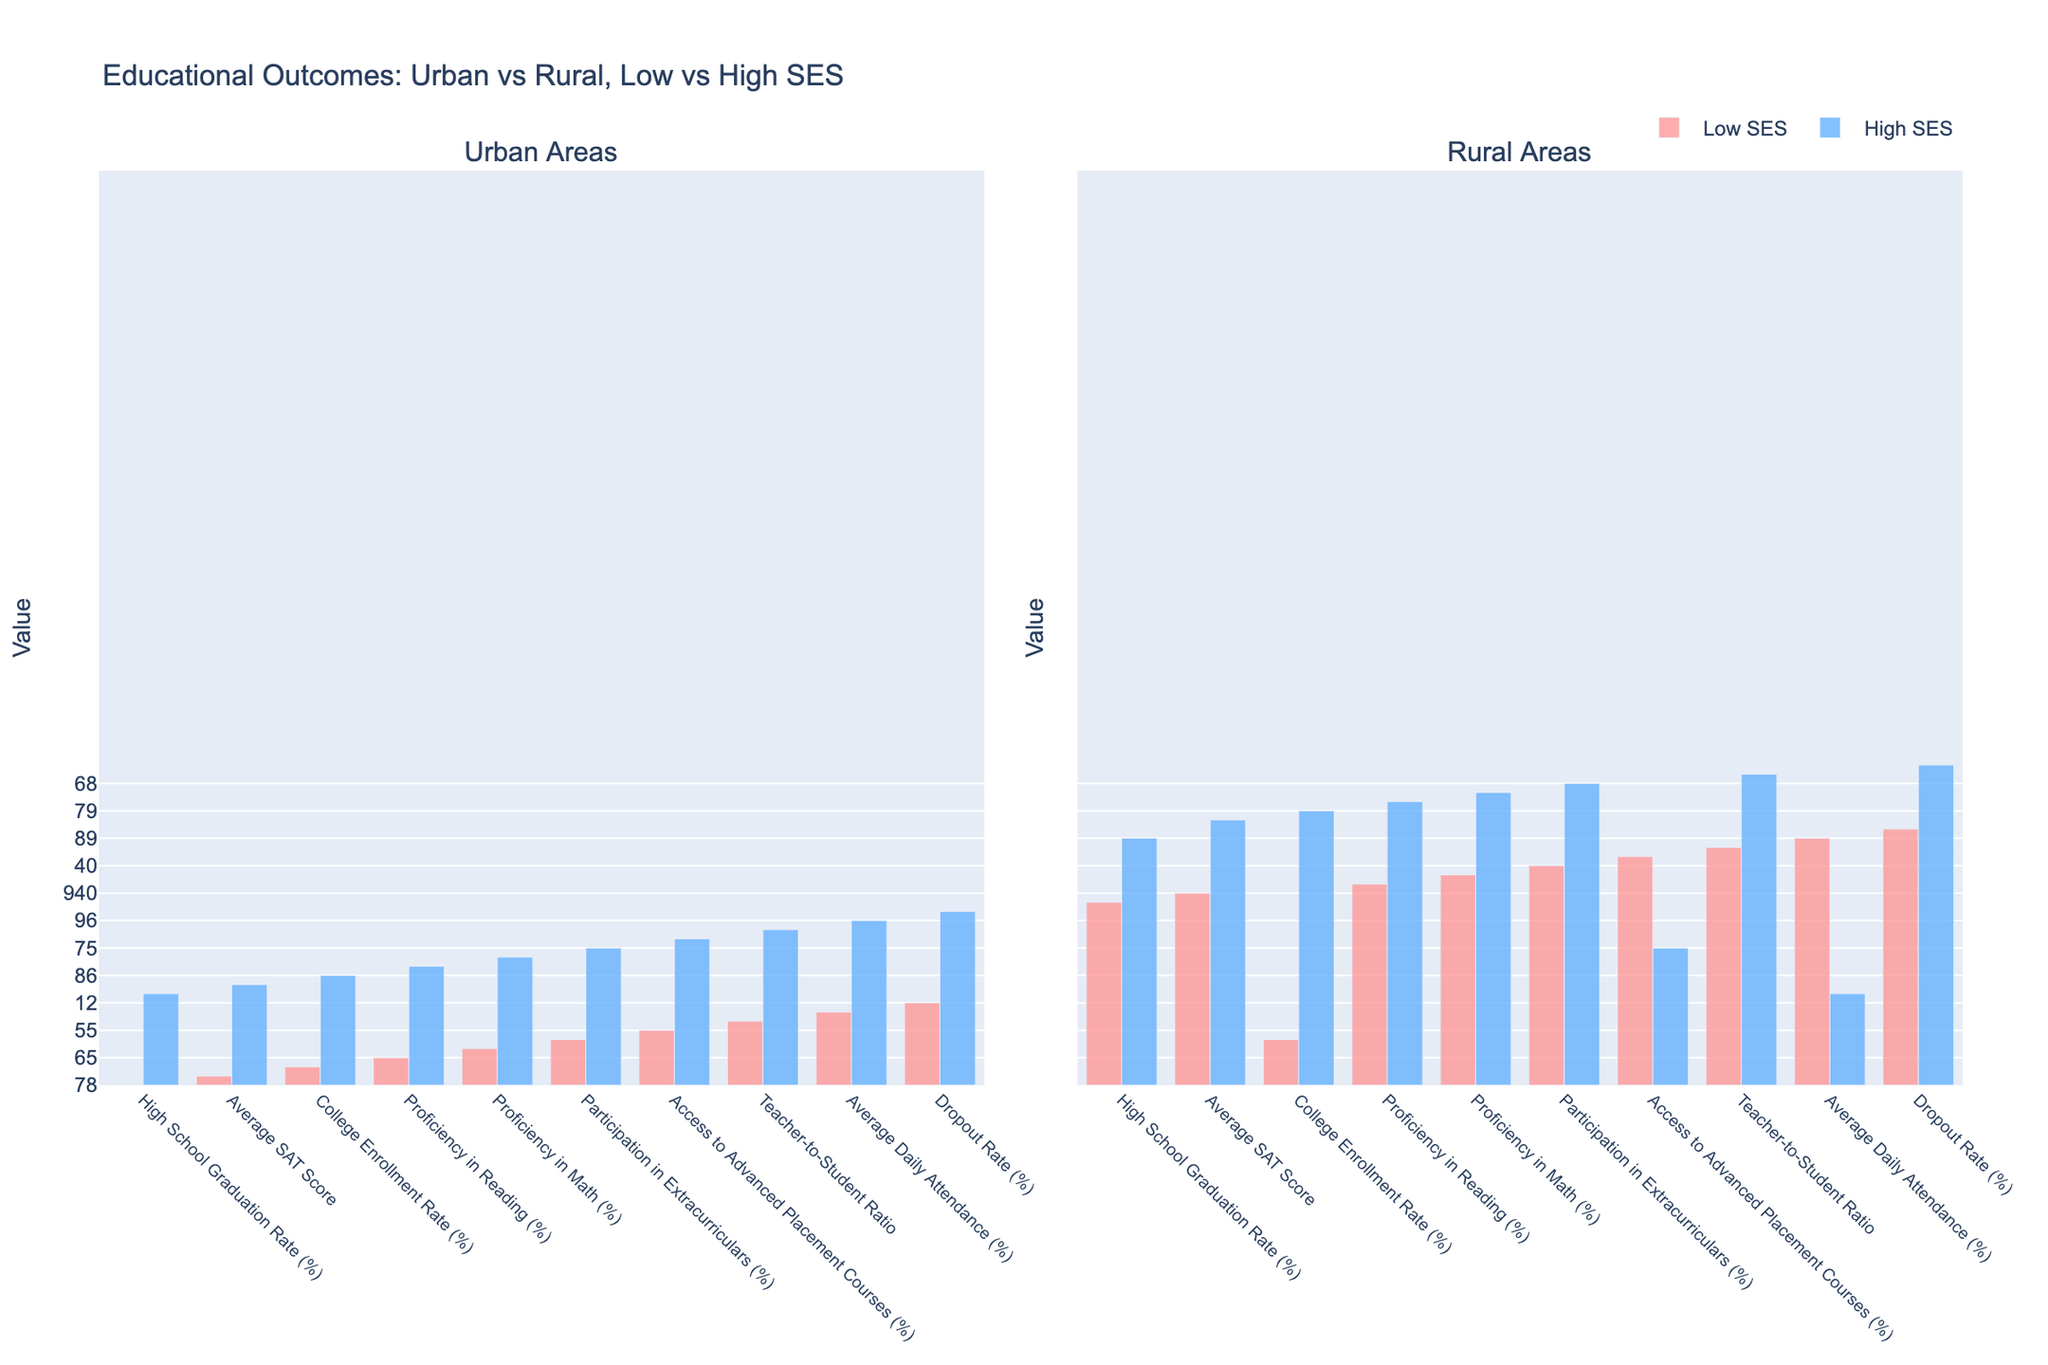Which group has the highest access to advanced placement courses in urban areas? The bar for Urban High SES shows the highest access to advanced placement courses among urban groups.
Answer: Urban High SES How much higher is the college enrollment rate for Urban High SES compared to Urban Low SES? The college enrollment rate for Urban High SES is 86%, and for Urban Low SES, it is 52%. Subtracting 52 from 86 gives 34.
Answer: 34% Which group has the lowest average SAT score? Among the groups shown, the Rural Low SES has the lowest average SAT score.
Answer: Rural Low SES What is the difference in high school graduation rates between Rural High SES and Urban Low SES? Rural High SES has a graduation rate of 89%, and Urban Low SES has 78%. Subtracting 78 from 89 gives 11.
Answer: 11% Compare the proficiency in math between Urban Low SES and Urban High SES. Which one is higher and by how much? Urban High SES has a math proficiency of 85%, and Urban Low SES has 58%. Subtracting 58 from 85 gives 27. Urban High SES is higher by 27%.
Answer: Urban High SES by 27% What is the average participation in extracurriculars for all four groups? The participation rates are 45% (Urban Low SES), 75% (Urban High SES), 40% (Rural Low SES), and 68% (Rural High SES). Summing these values (45 + 75 + 40 + 68) gives 228, and dividing by 4 gives 57%.
Answer: 57% Which socioeconomic status group has a higher dropout rate in rural areas? Rural Low SES has a dropout rate of 15%, compared to Rural High SES's 5%.
Answer: Rural Low SES Is the teacher-to-student ratio better in urban high SES or rural high SES? Urban High SES has a teacher-to-student ratio of 1:16, while Rural High SES has 1:14. Lower ratios indicate a better situation, so Rural High SES is better.
Answer: Rural High SES Which group has higher average daily attendance rates, and what are the rates? Urban High SES has the highest rate at 96%, compared to other groups that have 91% (Urban Low SES), 89% (Rural Low SES), and 94% (Rural High SES).
Answer: Urban High SES 